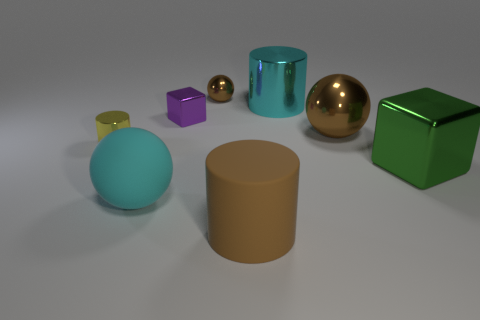Is the color of the big shiny cylinder the same as the matte sphere?
Your answer should be compact. Yes. How many big brown objects are the same shape as the yellow metal thing?
Keep it short and to the point. 1. The thing behind the cyan thing behind the tiny cylinder is what shape?
Give a very brief answer. Sphere. Do the sphere that is to the right of the brown matte thing and the rubber cylinder have the same size?
Provide a succinct answer. Yes. How big is the brown object that is on the left side of the cyan cylinder and in front of the small brown thing?
Your response must be concise. Large. How many purple shiny blocks are the same size as the yellow object?
Ensure brevity in your answer.  1. What number of brown objects are on the left side of the yellow object behind the cyan matte object?
Your response must be concise. 0. Do the large cylinder behind the big cube and the large metal cube have the same color?
Keep it short and to the point. No. There is a large green metallic thing that is in front of the metal cylinder that is in front of the big brown sphere; is there a large shiny cylinder that is behind it?
Offer a very short reply. Yes. The thing that is to the left of the purple metal cube and to the right of the yellow cylinder has what shape?
Give a very brief answer. Sphere. 